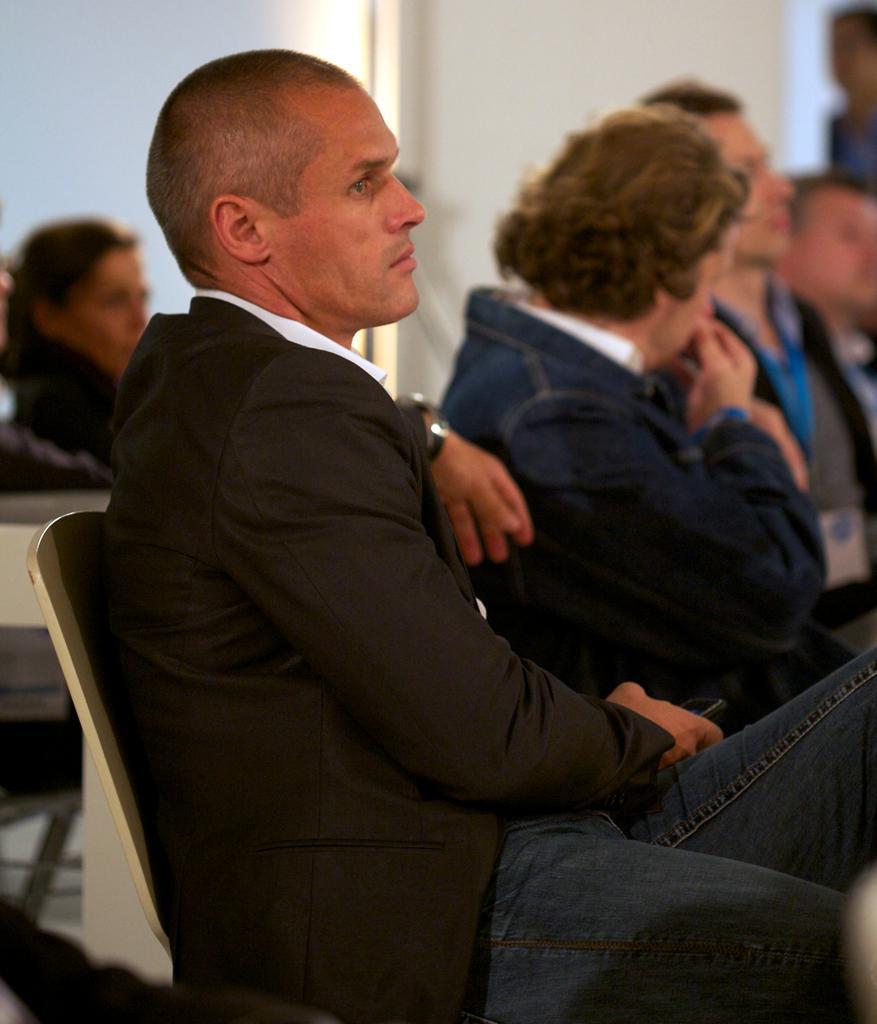How would you summarize this image in a sentence or two? The person wearing black suit is sitting on a chair and there are group of people sitting beside him. 